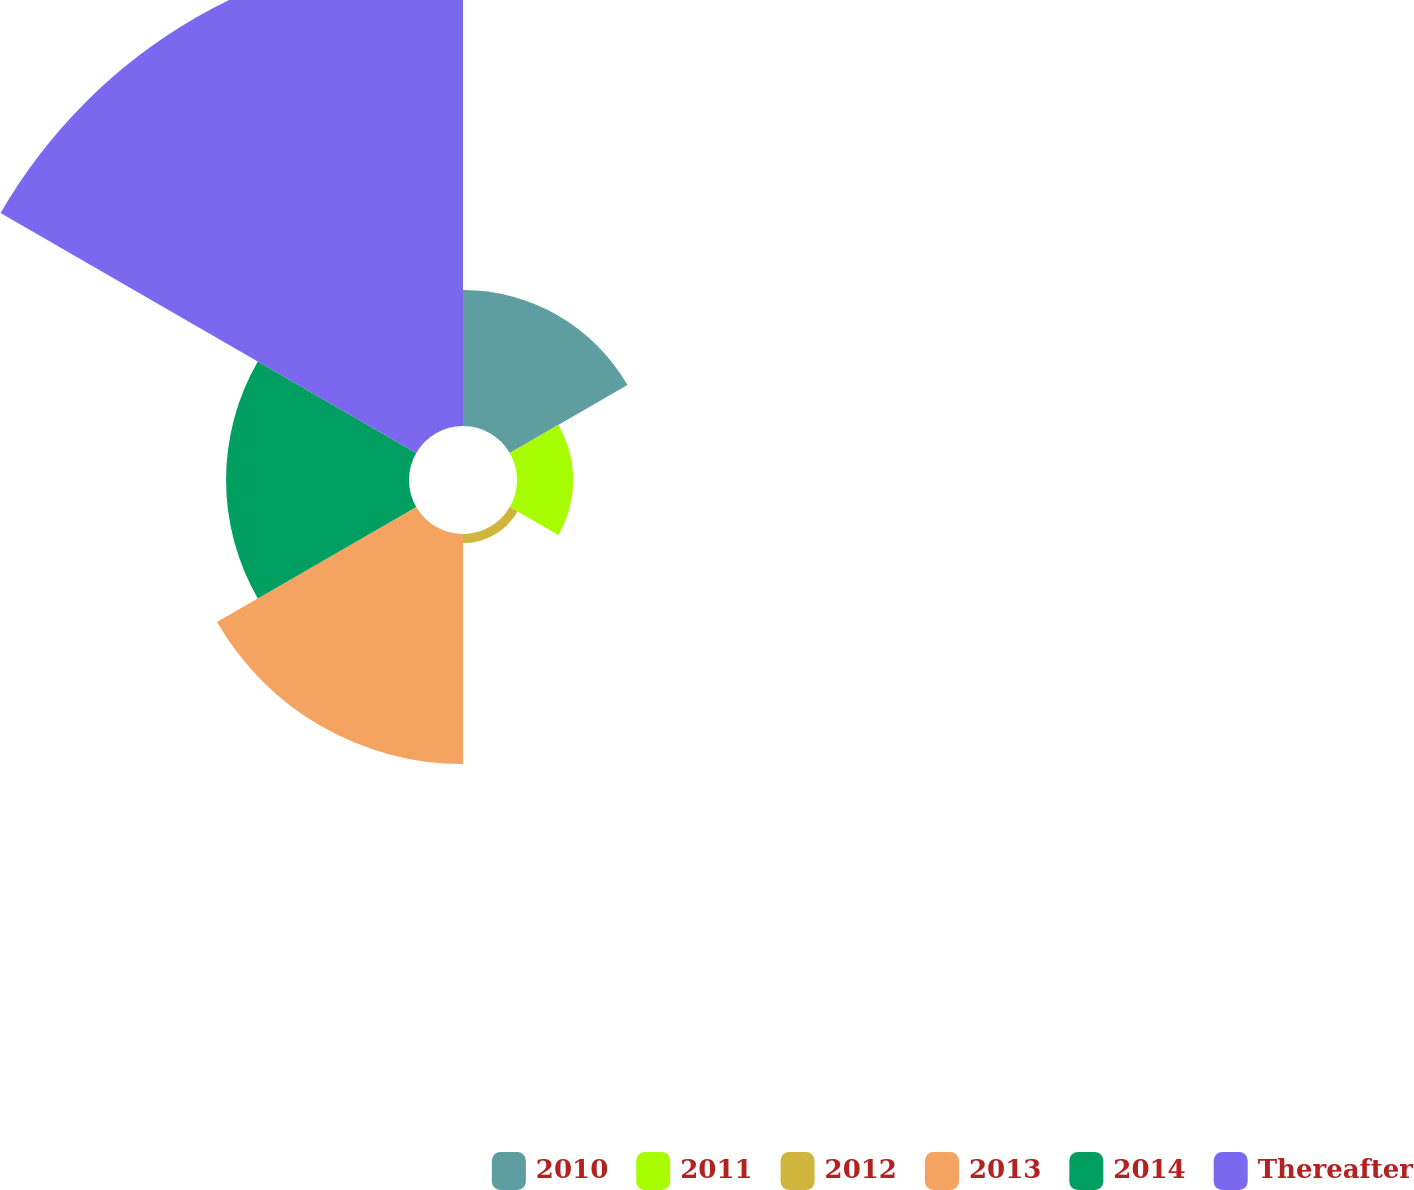Convert chart to OTSL. <chart><loc_0><loc_0><loc_500><loc_500><pie_chart><fcel>2010<fcel>2011<fcel>2012<fcel>2013<fcel>2014<fcel>Thereafter<nl><fcel>12.42%<fcel>5.13%<fcel>0.83%<fcel>21.03%<fcel>16.72%<fcel>43.87%<nl></chart> 